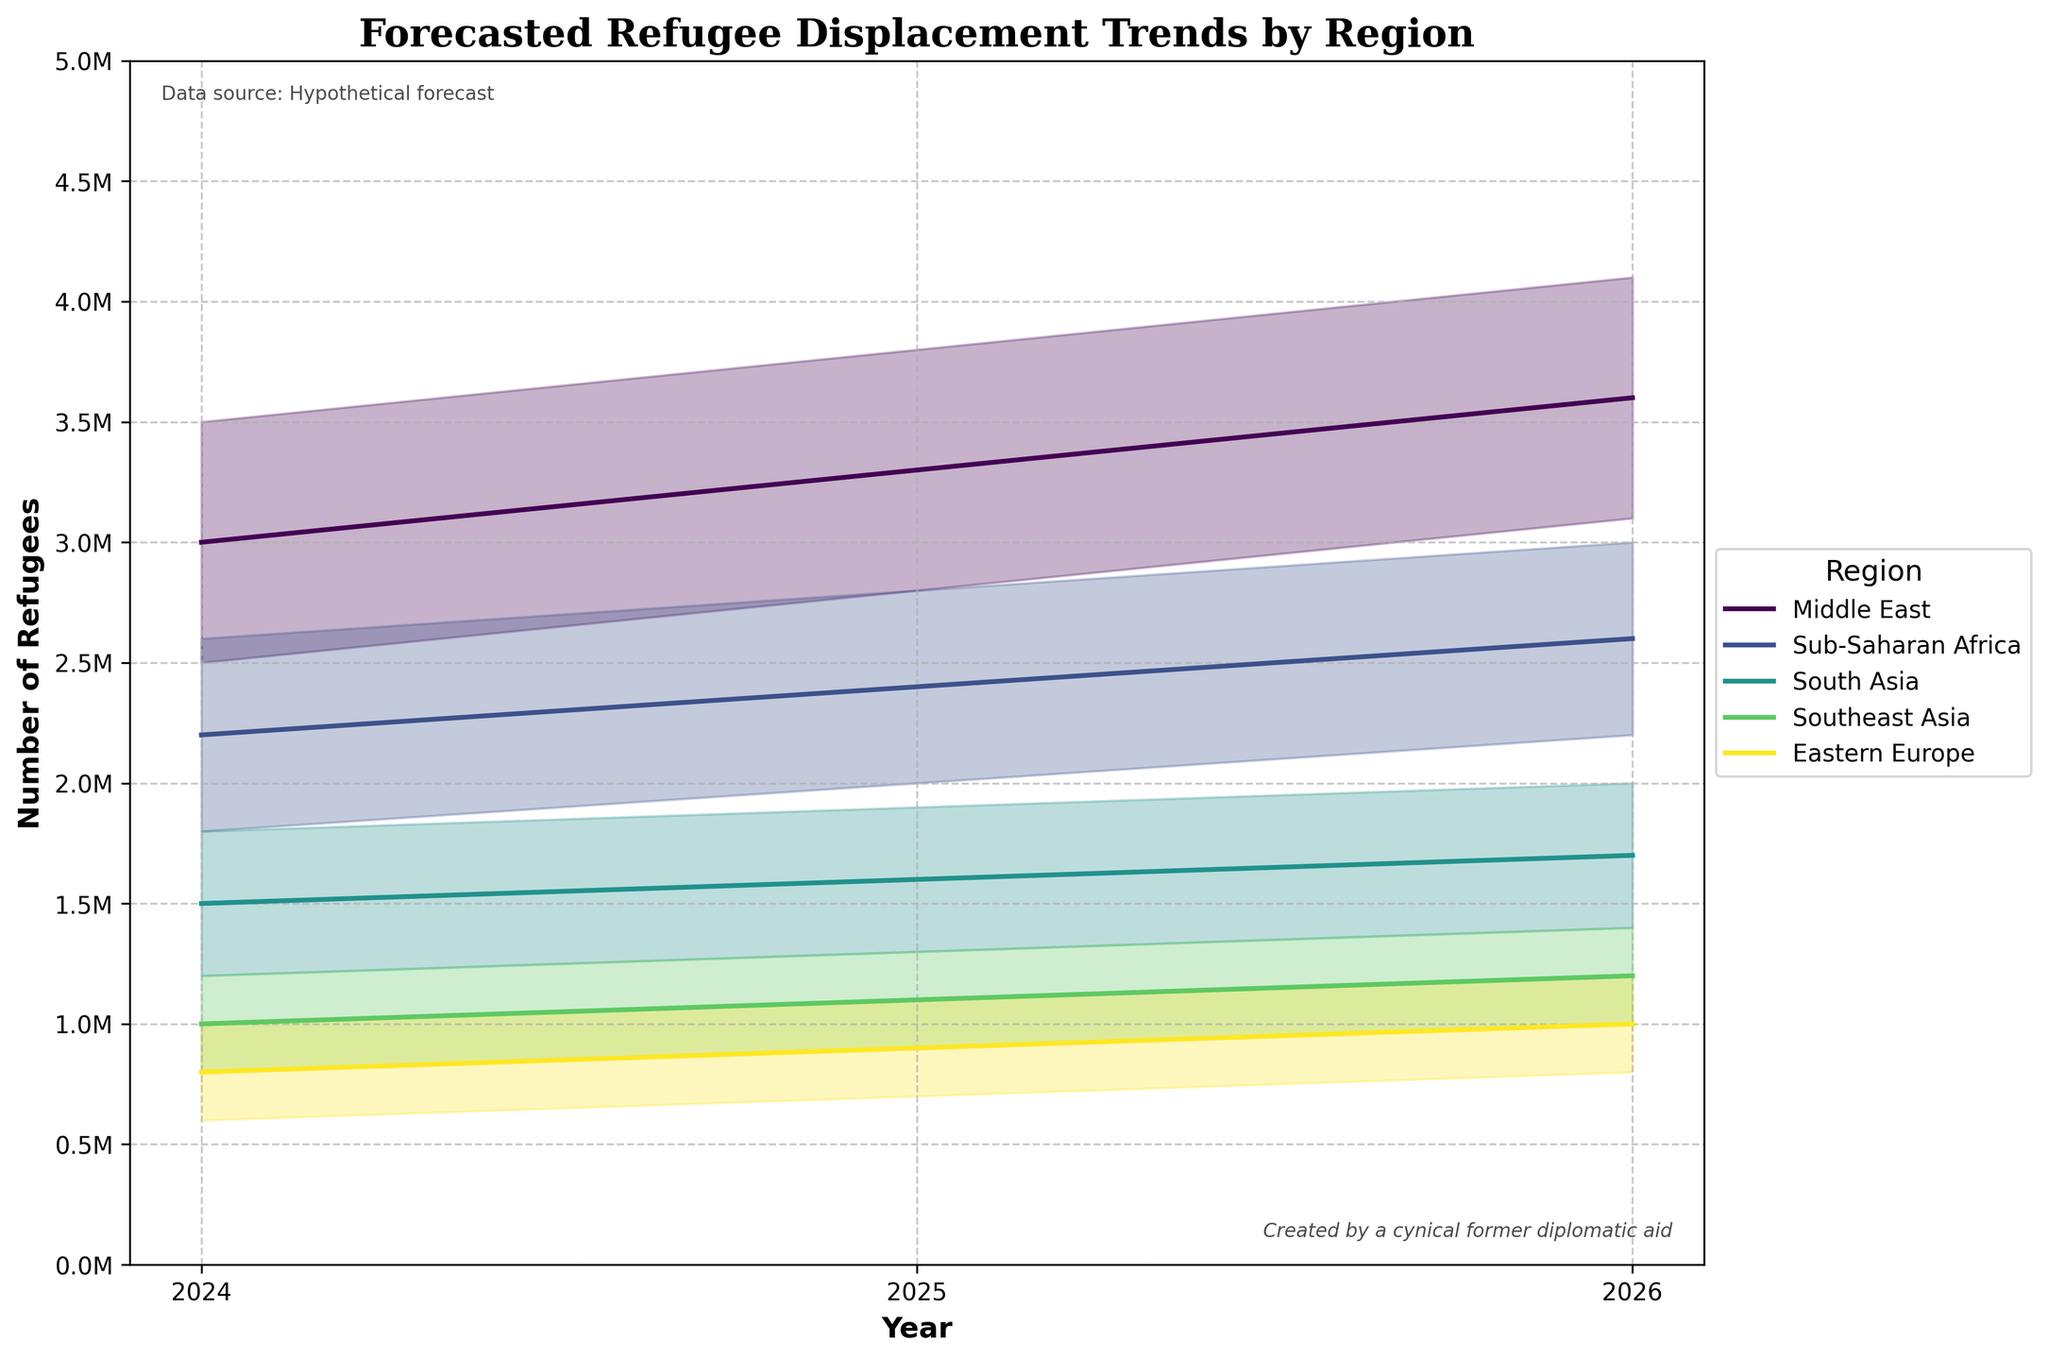What is the title of the figure? The title is clearly displayed at the top of the figure. It reads "Forecasted Refugee Displacement Trends by Region"
Answer: Forecasted Refugee Displacement Trends by Region Which region has the highest mid estimate for refugee displacement in 2026? According to the plot, the mid estimate for the Middle East in 2026 is the highest compared to other regions
Answer: Middle East What is the range of refugee displacement estimates for Sub-Saharan Africa in 2024? The range can be determined by looking at the low and high estimates for 2024 for Sub-Saharan Africa, which are 1,800,000 and 2,600,000 respectively
Answer: 800,000 By how much does the mid estimate for the Middle East increase from 2024 to 2025? The mid estimate for the Middle East in 2024 is 3,000,000 and in 2025 is 3,300,000. The difference is 3,300,000 - 3,000,000
Answer: 300,000 Which region shows the least variability in its refugee displacement estimates in 2026? Variability can be observed by the width of the shaded region between the low and high estimates. Eastern Europe has the smallest range in 2026 with low estimate 800,000 and high estimate 1,200,000
Answer: Eastern Europe In which year does Southeast Asia have a mid estimate of 1,000,000 refugee displacements? By observing the mid-estimate line for Southeast Asia, the year where it hits 1,000,000 is 2024
Answer: 2024 Which regions have a consistent increase in refugee displacement mid estimates over the three years? A consistent increase is shown by a continuous upward trend in the mid estimates line. The Middle East, Sub-Saharan Africa, South Asia, Southeast Asia, and Eastern Europe all exhibit this pattern
Answer: Middle East, Sub-Saharan Africa, South Asia, Southeast Asia, Eastern Europe What is the difference between the high estimates of Sub-Saharan Africa and South Asia in 2025? The high estimate for Sub-Saharan Africa in 2025 is 2,800,000, and for South Asia is 1,900,000. The difference is 2,800,000 - 1,900,000
Answer: 900,000 Which region has the lowest mid estimate in 2025, and what is the value? By comparing the mid estimates for 2025, Southeast Asia has the lowest mid estimate at 1,100,000
Answer: Southeast Asia, 1,100,000 How do the forecasted refugee displacements for Sub-Saharan Africa and South Asia compare in 2026? By using the mid estimates, Sub-Saharan Africa has 2,600,000 while South Asia has 1,700,000. Sub-Saharan Africa’s mid estimate is higher
Answer: Sub-Saharan Africa has more 